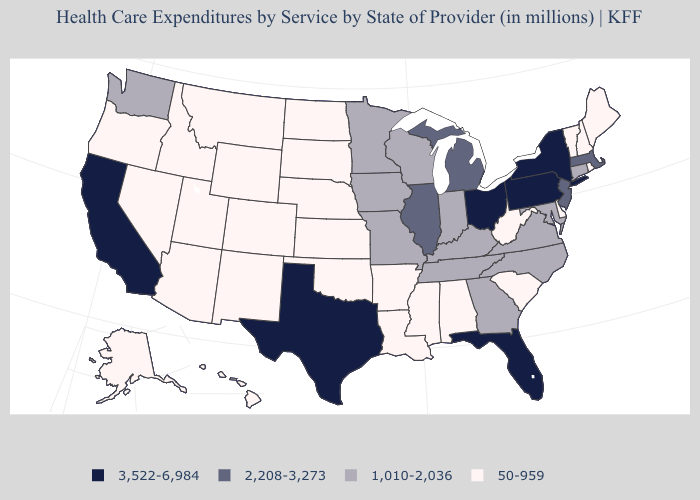Which states have the lowest value in the West?
Give a very brief answer. Alaska, Arizona, Colorado, Hawaii, Idaho, Montana, Nevada, New Mexico, Oregon, Utah, Wyoming. Among the states that border Michigan , does Indiana have the lowest value?
Be succinct. Yes. Does Florida have the highest value in the USA?
Short answer required. Yes. What is the value of Florida?
Answer briefly. 3,522-6,984. What is the lowest value in the USA?
Keep it brief. 50-959. Does Massachusetts have a higher value than California?
Quick response, please. No. Among the states that border Wisconsin , does Iowa have the highest value?
Concise answer only. No. What is the value of Arizona?
Short answer required. 50-959. Does California have the highest value in the USA?
Write a very short answer. Yes. What is the value of Iowa?
Be succinct. 1,010-2,036. Is the legend a continuous bar?
Short answer required. No. Name the states that have a value in the range 1,010-2,036?
Be succinct. Connecticut, Georgia, Indiana, Iowa, Kentucky, Maryland, Minnesota, Missouri, North Carolina, Tennessee, Virginia, Washington, Wisconsin. Name the states that have a value in the range 3,522-6,984?
Keep it brief. California, Florida, New York, Ohio, Pennsylvania, Texas. What is the highest value in the USA?
Give a very brief answer. 3,522-6,984. What is the lowest value in states that border North Dakota?
Answer briefly. 50-959. 